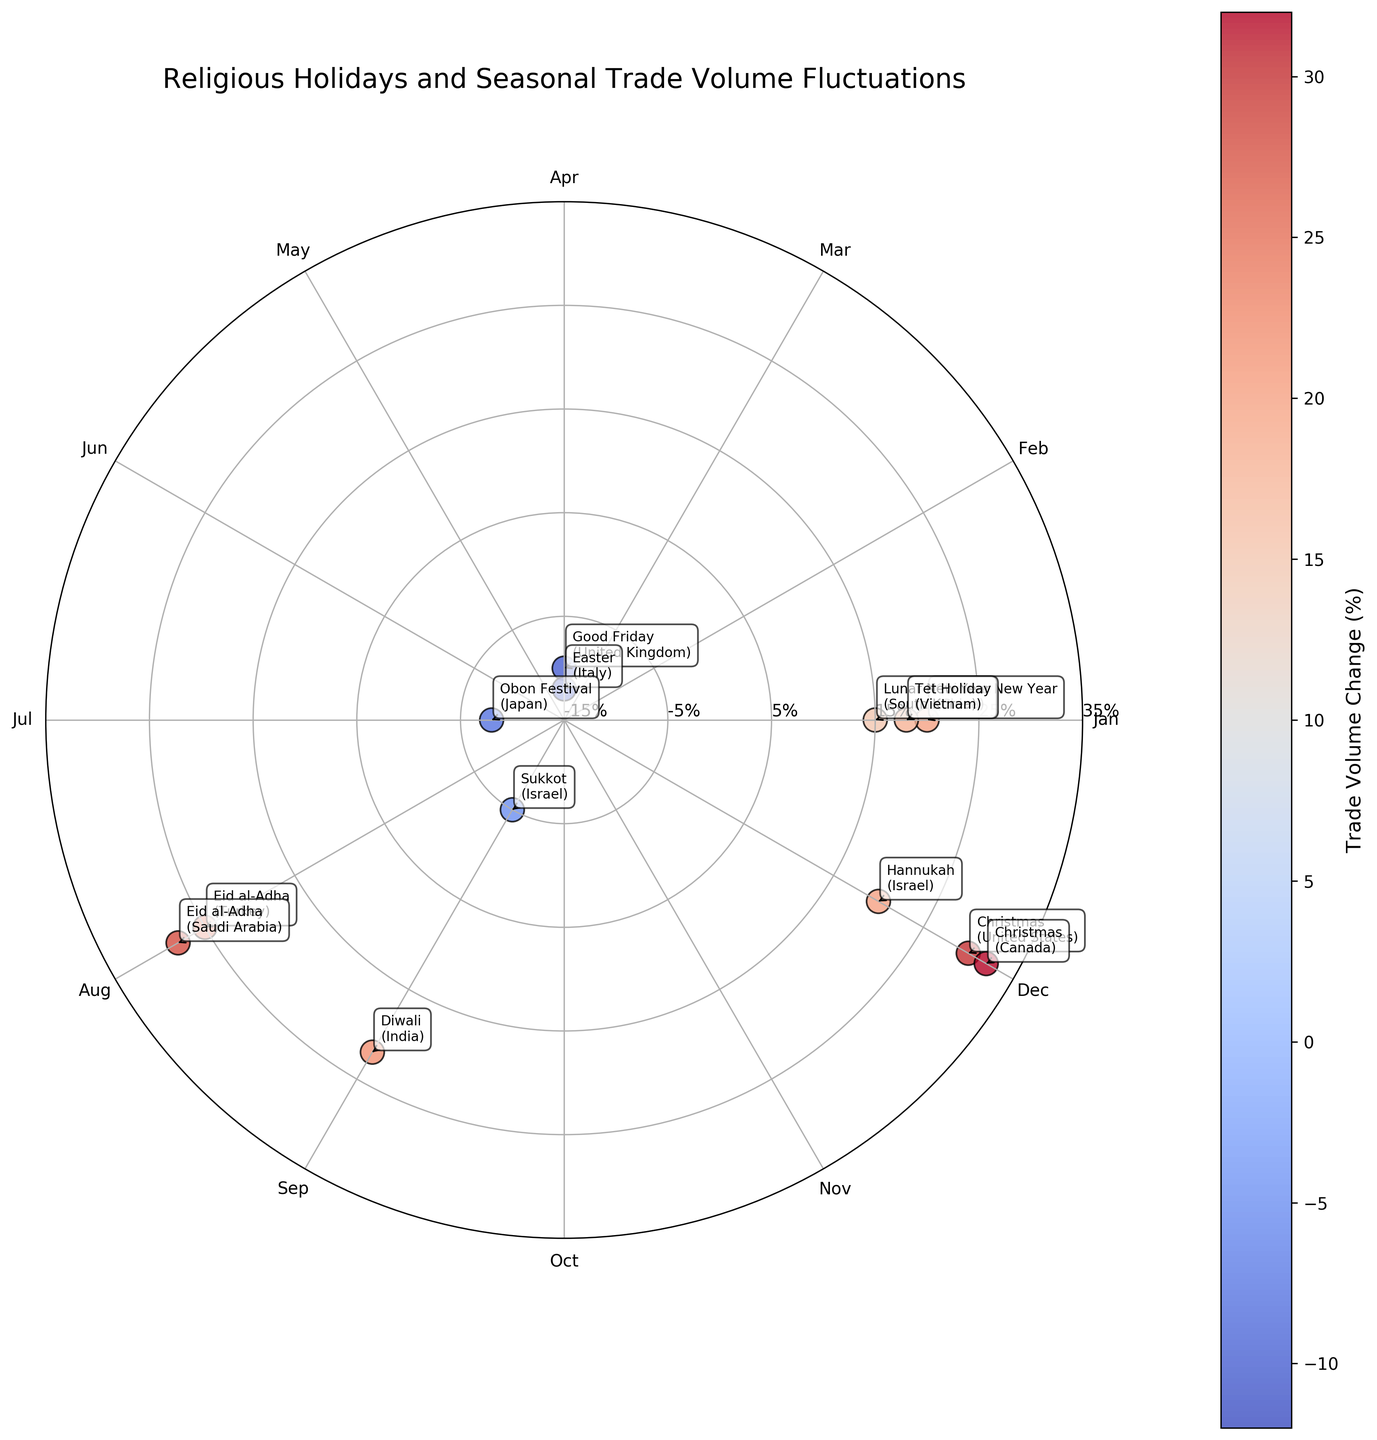What is the title of the Polar Scatter Chart? The title is usually found at the top of the figure. In this specific plot, the title is set to "Religious Holidays and Seasonal Trade Volume Fluctuations."
Answer: Religious Holidays and Seasonal Trade Volume Fluctuations How many data points are there in total? The number of data points is equivalent to the number of rows in the dataset provided, and each row is plotted as a point in the chart. There are 13 rows/data points in the given data.
Answer: 13 Which month shows the highest positive change in trade volume and what is the value? By examining the plotted points on the radial axis (trade volume change), the dot farthest from the center in a positive direction indicates the highest value. Looking at the annotations, December (Christmas in Canada) has the highest positive change at 32%.
Answer: December, 32% Which religious holiday in August has the higher trade volume change? Both data points representing religious holidays in August have different trade volume changes. Comparing these values, Eid al-Adha in Saudi Arabia has a change of 28%, which is higher than 25% for Turkey.
Answer: Eid al-Adha (Saudi Arabia) Which country's religious holiday shows the lowest negative trade volume change and what is the value? Checking the radial axis for the lowest negative value and the corresponding annotation, Good Friday in the United Kingdom has the lowest change at -10%.
Answer: United Kingdom, -10% How many religious holidays in the dataset occur in January? By looking at the plotted points and their annotations, January has three holidays: Chinese New Year (China), Lunar New Year (South Korea), and Tet Holiday (Vietnam).
Answer: 3 What is the average trade volume change in December? Identify the trade volume changes for December: Christmas in the USA (30), Christmas in Canada (32), and Hanukkah in Israel (20). Sum these values (30 + 32 + 20 = 82) and divide by the number of data points in December (3). The average is 82 / 3 ≈ 27.33%.
Answer: 27.33% Which religious holiday leads to the highest negative impact on trade volume, and which month does it occur in? Checking the radial axis, the point farthest from the center in the negative direction indicates the highest negative impact. Good Friday (United Kingdom) in April has the negative change of -10%.
Answer: Good Friday, April What months show no change in trade volume based on the dataset? Only data points on the radial axis at zero would show no change, but none of the given points lie at zero; all have either positive or negative changes. Therefore, no month shows zero change in trade volume.
Answer: None Comparing China and Japan, which country shows a greater impact on trade volume during their respective holidays? By comparing the trade volume changes during the Chinese New Year in China (20) and the Obon Festival in Japan (-8), China shows a greater (positive) impact on trade volume.
Answer: China 